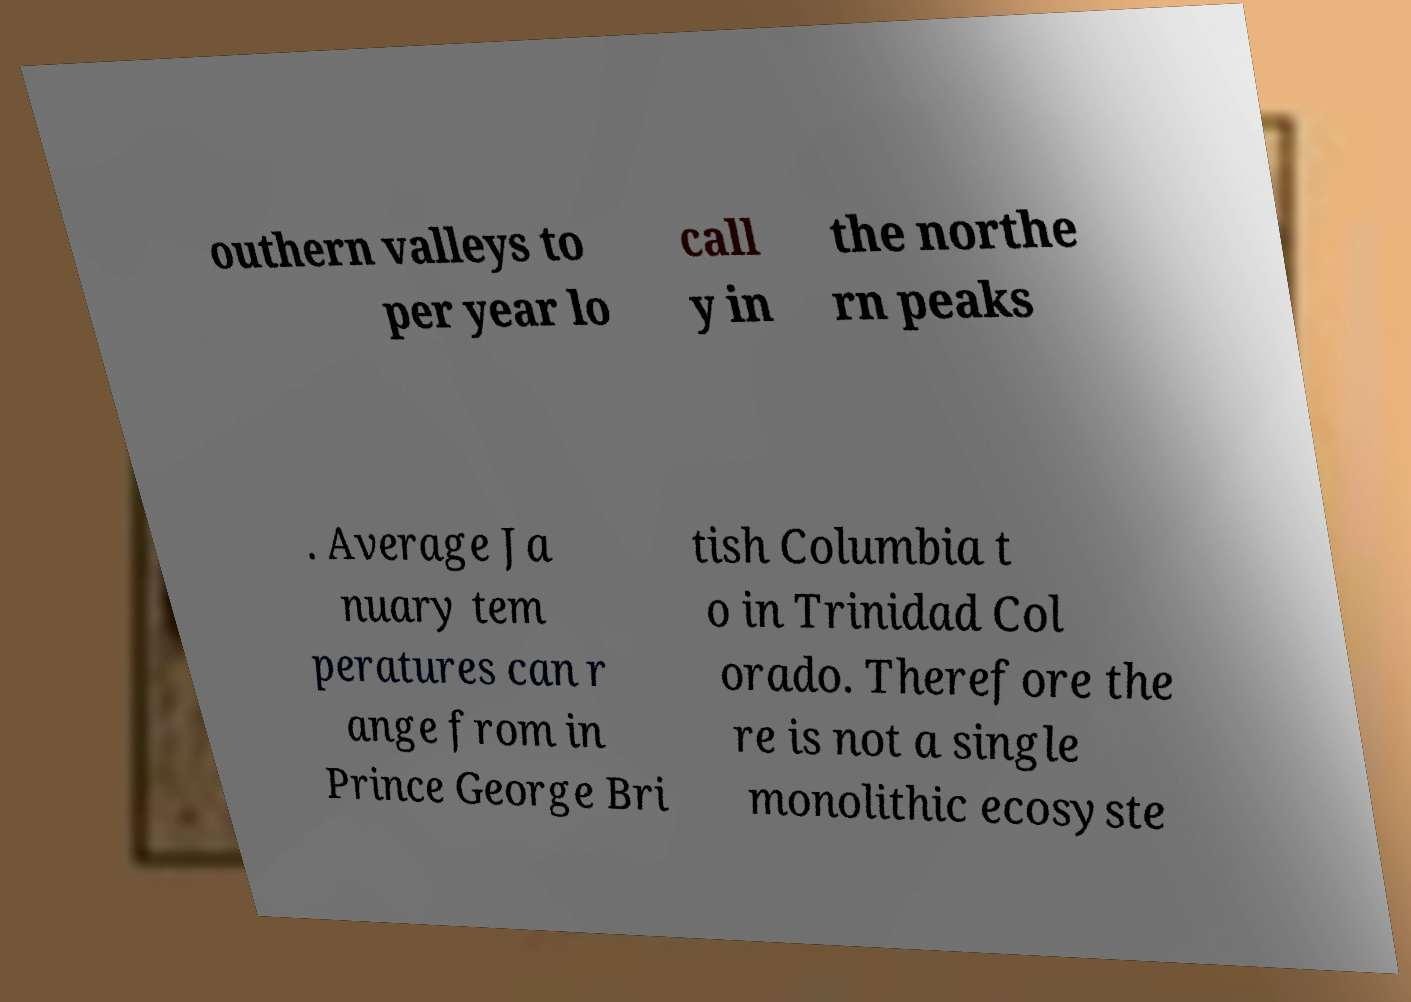For documentation purposes, I need the text within this image transcribed. Could you provide that? outhern valleys to per year lo call y in the northe rn peaks . Average Ja nuary tem peratures can r ange from in Prince George Bri tish Columbia t o in Trinidad Col orado. Therefore the re is not a single monolithic ecosyste 